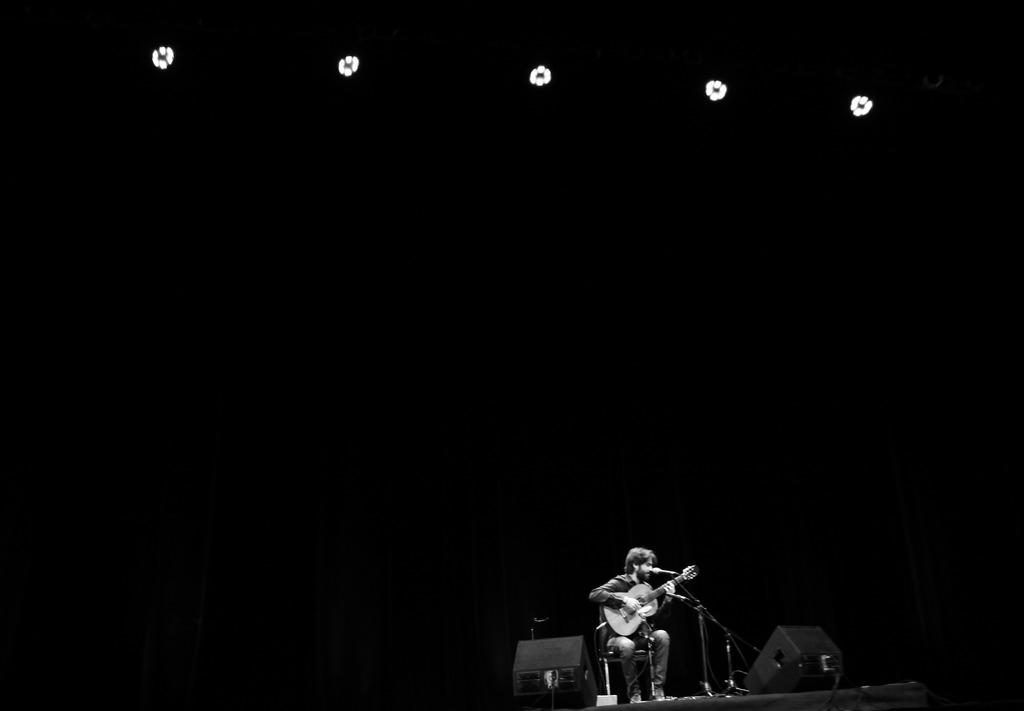What type of lights can be seen in the image? There are focusing lights in the image. What is the person in the image doing? The person is sitting on a chair and playing a guitar. What object is present for amplifying the person's voice? There is a microphone in the image. Can you see the person jumping in the image? No, the person is sitting on a chair and playing a guitar, not jumping. What type of corn is being used as a prop in the image? There is no corn present in the image. 